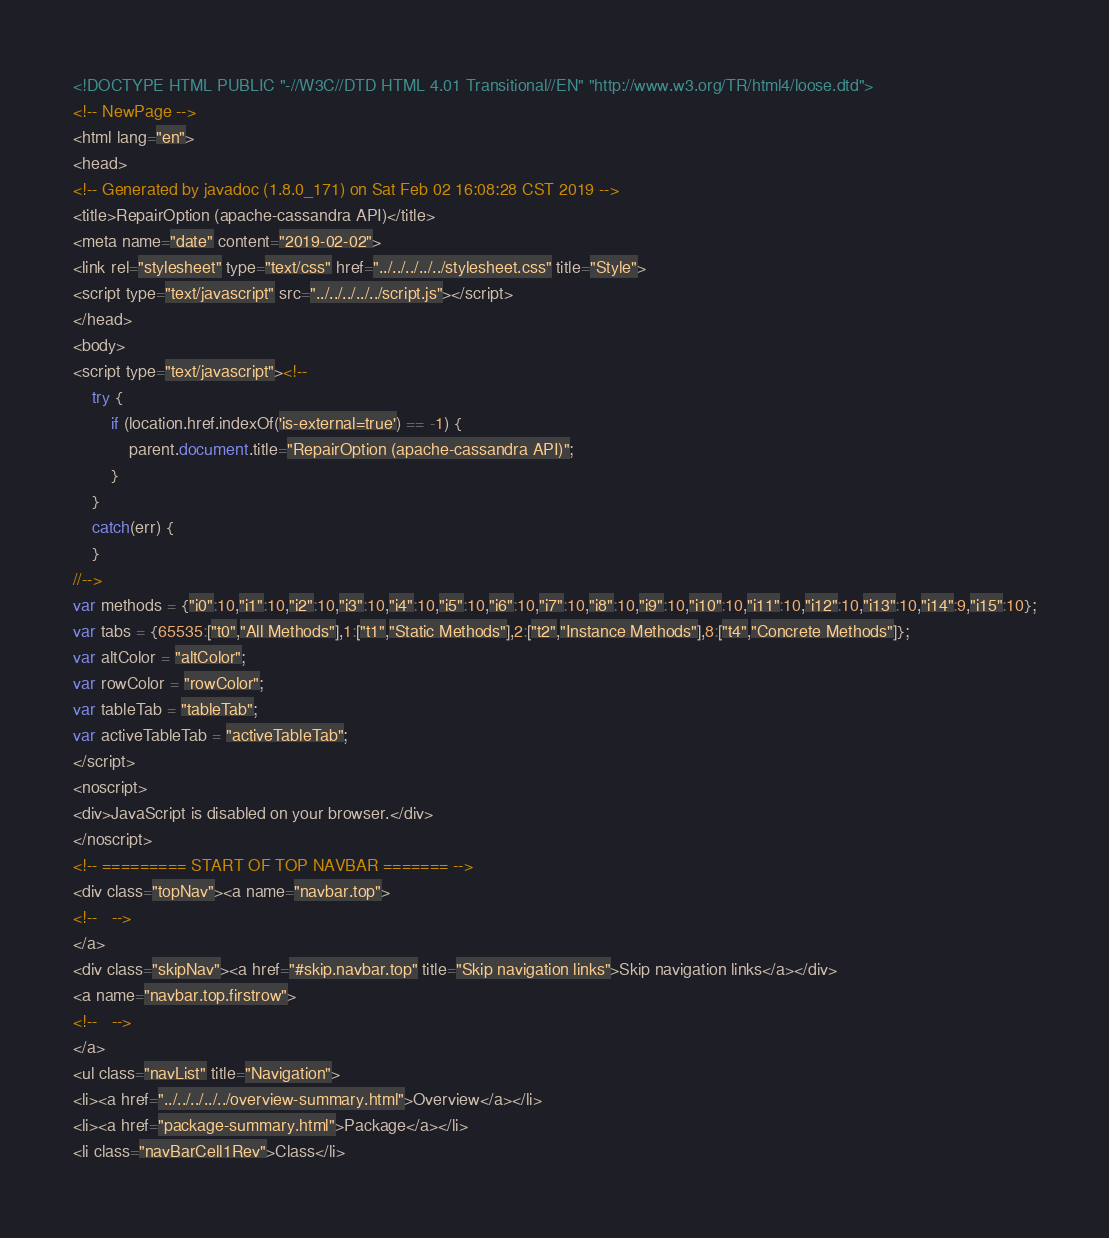<code> <loc_0><loc_0><loc_500><loc_500><_HTML_><!DOCTYPE HTML PUBLIC "-//W3C//DTD HTML 4.01 Transitional//EN" "http://www.w3.org/TR/html4/loose.dtd">
<!-- NewPage -->
<html lang="en">
<head>
<!-- Generated by javadoc (1.8.0_171) on Sat Feb 02 16:08:28 CST 2019 -->
<title>RepairOption (apache-cassandra API)</title>
<meta name="date" content="2019-02-02">
<link rel="stylesheet" type="text/css" href="../../../../../stylesheet.css" title="Style">
<script type="text/javascript" src="../../../../../script.js"></script>
</head>
<body>
<script type="text/javascript"><!--
    try {
        if (location.href.indexOf('is-external=true') == -1) {
            parent.document.title="RepairOption (apache-cassandra API)";
        }
    }
    catch(err) {
    }
//-->
var methods = {"i0":10,"i1":10,"i2":10,"i3":10,"i4":10,"i5":10,"i6":10,"i7":10,"i8":10,"i9":10,"i10":10,"i11":10,"i12":10,"i13":10,"i14":9,"i15":10};
var tabs = {65535:["t0","All Methods"],1:["t1","Static Methods"],2:["t2","Instance Methods"],8:["t4","Concrete Methods"]};
var altColor = "altColor";
var rowColor = "rowColor";
var tableTab = "tableTab";
var activeTableTab = "activeTableTab";
</script>
<noscript>
<div>JavaScript is disabled on your browser.</div>
</noscript>
<!-- ========= START OF TOP NAVBAR ======= -->
<div class="topNav"><a name="navbar.top">
<!--   -->
</a>
<div class="skipNav"><a href="#skip.navbar.top" title="Skip navigation links">Skip navigation links</a></div>
<a name="navbar.top.firstrow">
<!--   -->
</a>
<ul class="navList" title="Navigation">
<li><a href="../../../../../overview-summary.html">Overview</a></li>
<li><a href="package-summary.html">Package</a></li>
<li class="navBarCell1Rev">Class</li></code> 